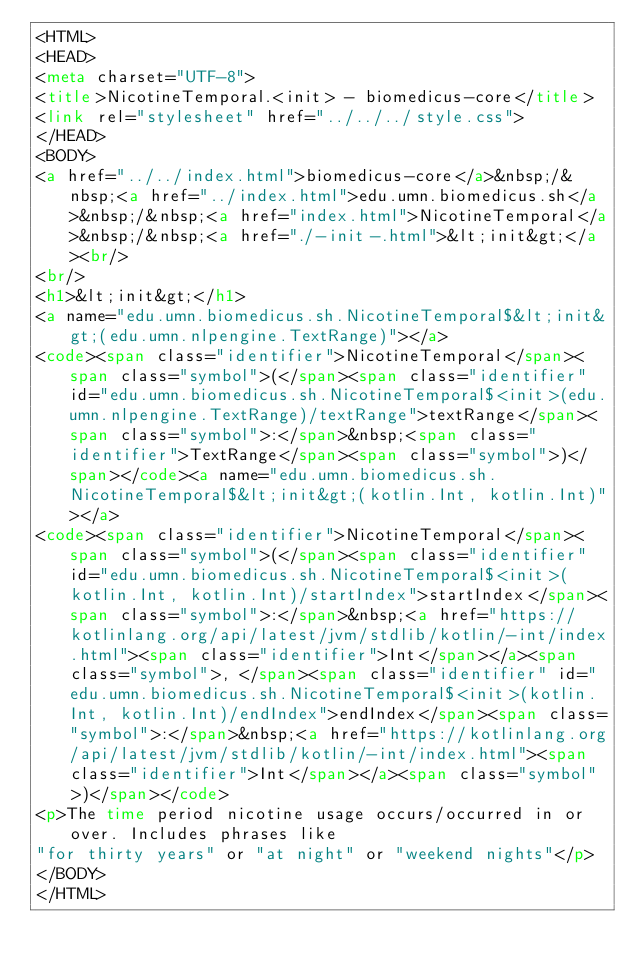Convert code to text. <code><loc_0><loc_0><loc_500><loc_500><_HTML_><HTML>
<HEAD>
<meta charset="UTF-8">
<title>NicotineTemporal.<init> - biomedicus-core</title>
<link rel="stylesheet" href="../../../style.css">
</HEAD>
<BODY>
<a href="../../index.html">biomedicus-core</a>&nbsp;/&nbsp;<a href="../index.html">edu.umn.biomedicus.sh</a>&nbsp;/&nbsp;<a href="index.html">NicotineTemporal</a>&nbsp;/&nbsp;<a href="./-init-.html">&lt;init&gt;</a><br/>
<br/>
<h1>&lt;init&gt;</h1>
<a name="edu.umn.biomedicus.sh.NicotineTemporal$&lt;init&gt;(edu.umn.nlpengine.TextRange)"></a>
<code><span class="identifier">NicotineTemporal</span><span class="symbol">(</span><span class="identifier" id="edu.umn.biomedicus.sh.NicotineTemporal$<init>(edu.umn.nlpengine.TextRange)/textRange">textRange</span><span class="symbol">:</span>&nbsp;<span class="identifier">TextRange</span><span class="symbol">)</span></code><a name="edu.umn.biomedicus.sh.NicotineTemporal$&lt;init&gt;(kotlin.Int, kotlin.Int)"></a>
<code><span class="identifier">NicotineTemporal</span><span class="symbol">(</span><span class="identifier" id="edu.umn.biomedicus.sh.NicotineTemporal$<init>(kotlin.Int, kotlin.Int)/startIndex">startIndex</span><span class="symbol">:</span>&nbsp;<a href="https://kotlinlang.org/api/latest/jvm/stdlib/kotlin/-int/index.html"><span class="identifier">Int</span></a><span class="symbol">, </span><span class="identifier" id="edu.umn.biomedicus.sh.NicotineTemporal$<init>(kotlin.Int, kotlin.Int)/endIndex">endIndex</span><span class="symbol">:</span>&nbsp;<a href="https://kotlinlang.org/api/latest/jvm/stdlib/kotlin/-int/index.html"><span class="identifier">Int</span></a><span class="symbol">)</span></code>
<p>The time period nicotine usage occurs/occurred in or over. Includes phrases like
"for thirty years" or "at night" or "weekend nights"</p>
</BODY>
</HTML>
</code> 